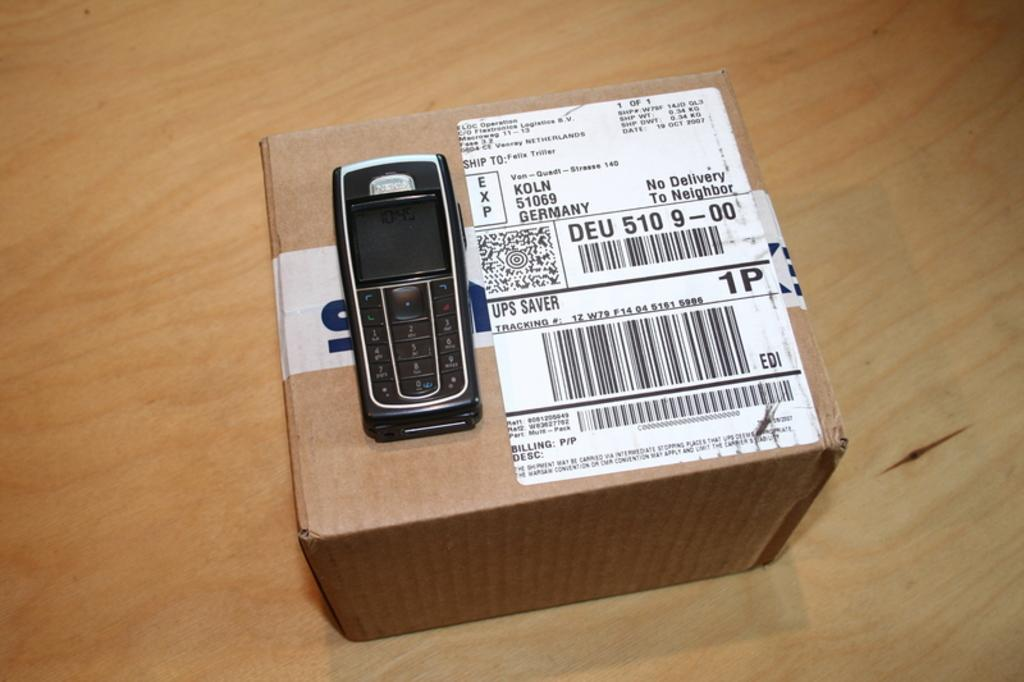Provide a one-sentence caption for the provided image. A black Nokia cellphone sitting atop an unopened mail parcel. 